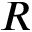<formula> <loc_0><loc_0><loc_500><loc_500>R</formula> 